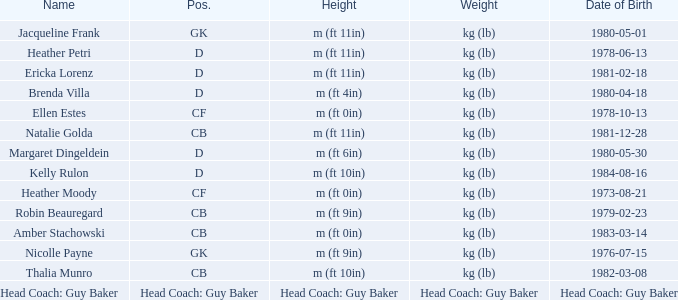Born on 1973-08-21, what is the cf's name? Heather Moody. 